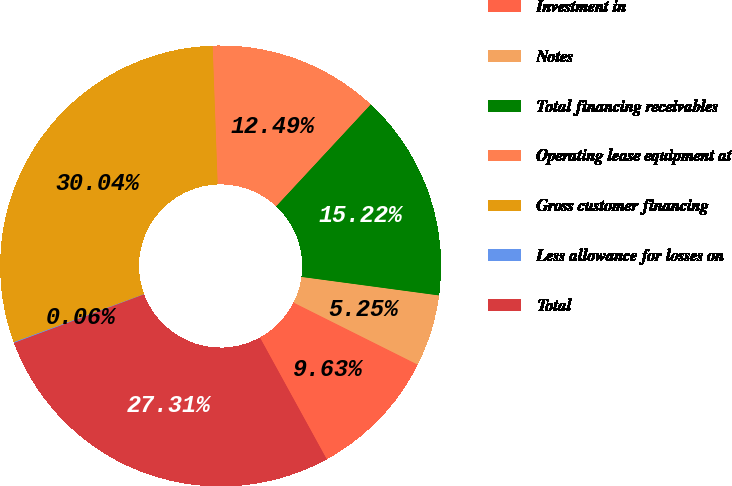Convert chart. <chart><loc_0><loc_0><loc_500><loc_500><pie_chart><fcel>Investment in<fcel>Notes<fcel>Total financing receivables<fcel>Operating lease equipment at<fcel>Gross customer financing<fcel>Less allowance for losses on<fcel>Total<nl><fcel>9.63%<fcel>5.25%<fcel>15.22%<fcel>12.49%<fcel>30.04%<fcel>0.06%<fcel>27.31%<nl></chart> 